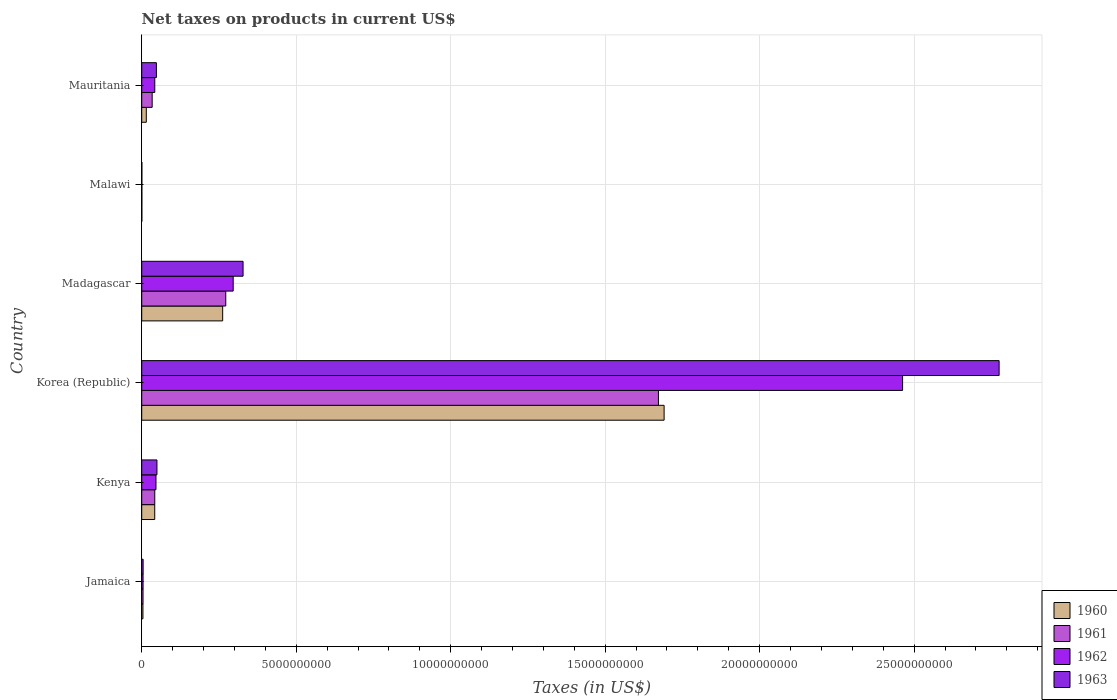How many different coloured bars are there?
Offer a very short reply. 4. How many bars are there on the 6th tick from the bottom?
Make the answer very short. 4. What is the label of the 6th group of bars from the top?
Offer a terse response. Jamaica. In how many cases, is the number of bars for a given country not equal to the number of legend labels?
Provide a short and direct response. 0. What is the net taxes on products in 1963 in Kenya?
Your response must be concise. 4.93e+08. Across all countries, what is the maximum net taxes on products in 1961?
Give a very brief answer. 1.67e+1. Across all countries, what is the minimum net taxes on products in 1960?
Offer a terse response. 3.90e+06. In which country was the net taxes on products in 1962 maximum?
Make the answer very short. Korea (Republic). In which country was the net taxes on products in 1960 minimum?
Your answer should be compact. Malawi. What is the total net taxes on products in 1963 in the graph?
Offer a very short reply. 3.20e+1. What is the difference between the net taxes on products in 1961 in Jamaica and that in Madagascar?
Ensure brevity in your answer.  -2.68e+09. What is the difference between the net taxes on products in 1961 in Mauritania and the net taxes on products in 1960 in Madagascar?
Provide a short and direct response. -2.28e+09. What is the average net taxes on products in 1963 per country?
Keep it short and to the point. 5.34e+09. What is the difference between the net taxes on products in 1960 and net taxes on products in 1963 in Malawi?
Offer a terse response. -7.00e+05. What is the ratio of the net taxes on products in 1960 in Jamaica to that in Malawi?
Provide a succinct answer. 10.08. Is the net taxes on products in 1961 in Kenya less than that in Madagascar?
Keep it short and to the point. Yes. What is the difference between the highest and the second highest net taxes on products in 1962?
Ensure brevity in your answer.  2.17e+1. What is the difference between the highest and the lowest net taxes on products in 1962?
Offer a very short reply. 2.46e+1. Is it the case that in every country, the sum of the net taxes on products in 1962 and net taxes on products in 1963 is greater than the sum of net taxes on products in 1961 and net taxes on products in 1960?
Provide a succinct answer. No. What does the 2nd bar from the top in Madagascar represents?
Make the answer very short. 1962. What does the 4th bar from the bottom in Kenya represents?
Offer a terse response. 1963. How many bars are there?
Keep it short and to the point. 24. What is the difference between two consecutive major ticks on the X-axis?
Make the answer very short. 5.00e+09. Are the values on the major ticks of X-axis written in scientific E-notation?
Ensure brevity in your answer.  No. Where does the legend appear in the graph?
Ensure brevity in your answer.  Bottom right. How many legend labels are there?
Ensure brevity in your answer.  4. What is the title of the graph?
Your answer should be very brief. Net taxes on products in current US$. Does "1963" appear as one of the legend labels in the graph?
Provide a short and direct response. Yes. What is the label or title of the X-axis?
Your answer should be very brief. Taxes (in US$). What is the Taxes (in US$) in 1960 in Jamaica?
Your answer should be compact. 3.93e+07. What is the Taxes (in US$) in 1961 in Jamaica?
Give a very brief answer. 4.26e+07. What is the Taxes (in US$) of 1962 in Jamaica?
Your response must be concise. 4.35e+07. What is the Taxes (in US$) of 1963 in Jamaica?
Provide a short and direct response. 4.54e+07. What is the Taxes (in US$) of 1960 in Kenya?
Provide a short and direct response. 4.21e+08. What is the Taxes (in US$) in 1961 in Kenya?
Your answer should be compact. 4.22e+08. What is the Taxes (in US$) of 1962 in Kenya?
Your answer should be compact. 4.62e+08. What is the Taxes (in US$) of 1963 in Kenya?
Provide a succinct answer. 4.93e+08. What is the Taxes (in US$) in 1960 in Korea (Republic)?
Offer a very short reply. 1.69e+1. What is the Taxes (in US$) in 1961 in Korea (Republic)?
Offer a very short reply. 1.67e+1. What is the Taxes (in US$) in 1962 in Korea (Republic)?
Give a very brief answer. 2.46e+1. What is the Taxes (in US$) in 1963 in Korea (Republic)?
Ensure brevity in your answer.  2.77e+1. What is the Taxes (in US$) in 1960 in Madagascar?
Give a very brief answer. 2.62e+09. What is the Taxes (in US$) of 1961 in Madagascar?
Offer a very short reply. 2.72e+09. What is the Taxes (in US$) in 1962 in Madagascar?
Your answer should be compact. 2.96e+09. What is the Taxes (in US$) in 1963 in Madagascar?
Give a very brief answer. 3.28e+09. What is the Taxes (in US$) of 1960 in Malawi?
Keep it short and to the point. 3.90e+06. What is the Taxes (in US$) of 1961 in Malawi?
Offer a very short reply. 4.20e+06. What is the Taxes (in US$) of 1962 in Malawi?
Keep it short and to the point. 4.40e+06. What is the Taxes (in US$) of 1963 in Malawi?
Offer a very short reply. 4.60e+06. What is the Taxes (in US$) in 1960 in Mauritania?
Your answer should be compact. 1.48e+08. What is the Taxes (in US$) in 1961 in Mauritania?
Your answer should be very brief. 3.38e+08. What is the Taxes (in US$) in 1962 in Mauritania?
Keep it short and to the point. 4.23e+08. What is the Taxes (in US$) of 1963 in Mauritania?
Your answer should be very brief. 4.75e+08. Across all countries, what is the maximum Taxes (in US$) of 1960?
Offer a very short reply. 1.69e+1. Across all countries, what is the maximum Taxes (in US$) in 1961?
Make the answer very short. 1.67e+1. Across all countries, what is the maximum Taxes (in US$) of 1962?
Your answer should be compact. 2.46e+1. Across all countries, what is the maximum Taxes (in US$) of 1963?
Provide a short and direct response. 2.77e+1. Across all countries, what is the minimum Taxes (in US$) in 1960?
Offer a very short reply. 3.90e+06. Across all countries, what is the minimum Taxes (in US$) of 1961?
Offer a terse response. 4.20e+06. Across all countries, what is the minimum Taxes (in US$) in 1962?
Give a very brief answer. 4.40e+06. Across all countries, what is the minimum Taxes (in US$) of 1963?
Make the answer very short. 4.60e+06. What is the total Taxes (in US$) in 1960 in the graph?
Make the answer very short. 2.01e+1. What is the total Taxes (in US$) in 1961 in the graph?
Your answer should be very brief. 2.03e+1. What is the total Taxes (in US$) in 1962 in the graph?
Ensure brevity in your answer.  2.85e+1. What is the total Taxes (in US$) in 1963 in the graph?
Offer a terse response. 3.20e+1. What is the difference between the Taxes (in US$) of 1960 in Jamaica and that in Kenya?
Your answer should be compact. -3.82e+08. What is the difference between the Taxes (in US$) in 1961 in Jamaica and that in Kenya?
Provide a short and direct response. -3.79e+08. What is the difference between the Taxes (in US$) in 1962 in Jamaica and that in Kenya?
Provide a succinct answer. -4.18e+08. What is the difference between the Taxes (in US$) in 1963 in Jamaica and that in Kenya?
Your answer should be compact. -4.48e+08. What is the difference between the Taxes (in US$) of 1960 in Jamaica and that in Korea (Republic)?
Your response must be concise. -1.69e+1. What is the difference between the Taxes (in US$) of 1961 in Jamaica and that in Korea (Republic)?
Offer a terse response. -1.67e+1. What is the difference between the Taxes (in US$) in 1962 in Jamaica and that in Korea (Republic)?
Make the answer very short. -2.46e+1. What is the difference between the Taxes (in US$) of 1963 in Jamaica and that in Korea (Republic)?
Your answer should be compact. -2.77e+1. What is the difference between the Taxes (in US$) in 1960 in Jamaica and that in Madagascar?
Your answer should be compact. -2.58e+09. What is the difference between the Taxes (in US$) of 1961 in Jamaica and that in Madagascar?
Ensure brevity in your answer.  -2.68e+09. What is the difference between the Taxes (in US$) in 1962 in Jamaica and that in Madagascar?
Offer a terse response. -2.92e+09. What is the difference between the Taxes (in US$) of 1963 in Jamaica and that in Madagascar?
Keep it short and to the point. -3.23e+09. What is the difference between the Taxes (in US$) of 1960 in Jamaica and that in Malawi?
Your answer should be very brief. 3.54e+07. What is the difference between the Taxes (in US$) in 1961 in Jamaica and that in Malawi?
Provide a short and direct response. 3.84e+07. What is the difference between the Taxes (in US$) in 1962 in Jamaica and that in Malawi?
Your answer should be very brief. 3.91e+07. What is the difference between the Taxes (in US$) in 1963 in Jamaica and that in Malawi?
Make the answer very short. 4.08e+07. What is the difference between the Taxes (in US$) of 1960 in Jamaica and that in Mauritania?
Give a very brief answer. -1.09e+08. What is the difference between the Taxes (in US$) of 1961 in Jamaica and that in Mauritania?
Give a very brief answer. -2.95e+08. What is the difference between the Taxes (in US$) of 1962 in Jamaica and that in Mauritania?
Provide a succinct answer. -3.79e+08. What is the difference between the Taxes (in US$) in 1963 in Jamaica and that in Mauritania?
Provide a succinct answer. -4.30e+08. What is the difference between the Taxes (in US$) in 1960 in Kenya and that in Korea (Republic)?
Provide a succinct answer. -1.65e+1. What is the difference between the Taxes (in US$) in 1961 in Kenya and that in Korea (Republic)?
Ensure brevity in your answer.  -1.63e+1. What is the difference between the Taxes (in US$) of 1962 in Kenya and that in Korea (Republic)?
Ensure brevity in your answer.  -2.42e+1. What is the difference between the Taxes (in US$) in 1963 in Kenya and that in Korea (Republic)?
Offer a very short reply. -2.73e+1. What is the difference between the Taxes (in US$) in 1960 in Kenya and that in Madagascar?
Provide a short and direct response. -2.20e+09. What is the difference between the Taxes (in US$) in 1961 in Kenya and that in Madagascar?
Your answer should be very brief. -2.30e+09. What is the difference between the Taxes (in US$) in 1962 in Kenya and that in Madagascar?
Offer a terse response. -2.50e+09. What is the difference between the Taxes (in US$) in 1963 in Kenya and that in Madagascar?
Make the answer very short. -2.79e+09. What is the difference between the Taxes (in US$) in 1960 in Kenya and that in Malawi?
Give a very brief answer. 4.17e+08. What is the difference between the Taxes (in US$) of 1961 in Kenya and that in Malawi?
Give a very brief answer. 4.18e+08. What is the difference between the Taxes (in US$) in 1962 in Kenya and that in Malawi?
Keep it short and to the point. 4.57e+08. What is the difference between the Taxes (in US$) in 1963 in Kenya and that in Malawi?
Offer a terse response. 4.88e+08. What is the difference between the Taxes (in US$) in 1960 in Kenya and that in Mauritania?
Give a very brief answer. 2.73e+08. What is the difference between the Taxes (in US$) in 1961 in Kenya and that in Mauritania?
Keep it short and to the point. 8.39e+07. What is the difference between the Taxes (in US$) of 1962 in Kenya and that in Mauritania?
Keep it short and to the point. 3.92e+07. What is the difference between the Taxes (in US$) in 1963 in Kenya and that in Mauritania?
Your answer should be very brief. 1.76e+07. What is the difference between the Taxes (in US$) in 1960 in Korea (Republic) and that in Madagascar?
Your answer should be very brief. 1.43e+1. What is the difference between the Taxes (in US$) of 1961 in Korea (Republic) and that in Madagascar?
Make the answer very short. 1.40e+1. What is the difference between the Taxes (in US$) of 1962 in Korea (Republic) and that in Madagascar?
Your answer should be very brief. 2.17e+1. What is the difference between the Taxes (in US$) of 1963 in Korea (Republic) and that in Madagascar?
Offer a terse response. 2.45e+1. What is the difference between the Taxes (in US$) of 1960 in Korea (Republic) and that in Malawi?
Ensure brevity in your answer.  1.69e+1. What is the difference between the Taxes (in US$) in 1961 in Korea (Republic) and that in Malawi?
Make the answer very short. 1.67e+1. What is the difference between the Taxes (in US$) in 1962 in Korea (Republic) and that in Malawi?
Provide a succinct answer. 2.46e+1. What is the difference between the Taxes (in US$) in 1963 in Korea (Republic) and that in Malawi?
Provide a succinct answer. 2.77e+1. What is the difference between the Taxes (in US$) in 1960 in Korea (Republic) and that in Mauritania?
Give a very brief answer. 1.68e+1. What is the difference between the Taxes (in US$) of 1961 in Korea (Republic) and that in Mauritania?
Ensure brevity in your answer.  1.64e+1. What is the difference between the Taxes (in US$) in 1962 in Korea (Republic) and that in Mauritania?
Make the answer very short. 2.42e+1. What is the difference between the Taxes (in US$) in 1963 in Korea (Republic) and that in Mauritania?
Your answer should be very brief. 2.73e+1. What is the difference between the Taxes (in US$) of 1960 in Madagascar and that in Malawi?
Ensure brevity in your answer.  2.62e+09. What is the difference between the Taxes (in US$) in 1961 in Madagascar and that in Malawi?
Give a very brief answer. 2.72e+09. What is the difference between the Taxes (in US$) in 1962 in Madagascar and that in Malawi?
Ensure brevity in your answer.  2.96e+09. What is the difference between the Taxes (in US$) in 1963 in Madagascar and that in Malawi?
Keep it short and to the point. 3.28e+09. What is the difference between the Taxes (in US$) in 1960 in Madagascar and that in Mauritania?
Give a very brief answer. 2.47e+09. What is the difference between the Taxes (in US$) in 1961 in Madagascar and that in Mauritania?
Provide a short and direct response. 2.38e+09. What is the difference between the Taxes (in US$) in 1962 in Madagascar and that in Mauritania?
Your answer should be very brief. 2.54e+09. What is the difference between the Taxes (in US$) in 1963 in Madagascar and that in Mauritania?
Provide a succinct answer. 2.80e+09. What is the difference between the Taxes (in US$) of 1960 in Malawi and that in Mauritania?
Ensure brevity in your answer.  -1.44e+08. What is the difference between the Taxes (in US$) of 1961 in Malawi and that in Mauritania?
Give a very brief answer. -3.34e+08. What is the difference between the Taxes (in US$) of 1962 in Malawi and that in Mauritania?
Provide a short and direct response. -4.18e+08. What is the difference between the Taxes (in US$) of 1963 in Malawi and that in Mauritania?
Your answer should be very brief. -4.71e+08. What is the difference between the Taxes (in US$) of 1960 in Jamaica and the Taxes (in US$) of 1961 in Kenya?
Offer a terse response. -3.83e+08. What is the difference between the Taxes (in US$) in 1960 in Jamaica and the Taxes (in US$) in 1962 in Kenya?
Provide a short and direct response. -4.22e+08. What is the difference between the Taxes (in US$) in 1960 in Jamaica and the Taxes (in US$) in 1963 in Kenya?
Ensure brevity in your answer.  -4.54e+08. What is the difference between the Taxes (in US$) in 1961 in Jamaica and the Taxes (in US$) in 1962 in Kenya?
Offer a terse response. -4.19e+08. What is the difference between the Taxes (in US$) of 1961 in Jamaica and the Taxes (in US$) of 1963 in Kenya?
Your answer should be compact. -4.50e+08. What is the difference between the Taxes (in US$) of 1962 in Jamaica and the Taxes (in US$) of 1963 in Kenya?
Your response must be concise. -4.50e+08. What is the difference between the Taxes (in US$) in 1960 in Jamaica and the Taxes (in US$) in 1961 in Korea (Republic)?
Keep it short and to the point. -1.67e+1. What is the difference between the Taxes (in US$) in 1960 in Jamaica and the Taxes (in US$) in 1962 in Korea (Republic)?
Ensure brevity in your answer.  -2.46e+1. What is the difference between the Taxes (in US$) in 1960 in Jamaica and the Taxes (in US$) in 1963 in Korea (Republic)?
Your response must be concise. -2.77e+1. What is the difference between the Taxes (in US$) in 1961 in Jamaica and the Taxes (in US$) in 1962 in Korea (Republic)?
Offer a very short reply. -2.46e+1. What is the difference between the Taxes (in US$) of 1961 in Jamaica and the Taxes (in US$) of 1963 in Korea (Republic)?
Offer a terse response. -2.77e+1. What is the difference between the Taxes (in US$) in 1962 in Jamaica and the Taxes (in US$) in 1963 in Korea (Republic)?
Your answer should be compact. -2.77e+1. What is the difference between the Taxes (in US$) of 1960 in Jamaica and the Taxes (in US$) of 1961 in Madagascar?
Provide a succinct answer. -2.68e+09. What is the difference between the Taxes (in US$) in 1960 in Jamaica and the Taxes (in US$) in 1962 in Madagascar?
Offer a very short reply. -2.92e+09. What is the difference between the Taxes (in US$) of 1960 in Jamaica and the Taxes (in US$) of 1963 in Madagascar?
Make the answer very short. -3.24e+09. What is the difference between the Taxes (in US$) of 1961 in Jamaica and the Taxes (in US$) of 1962 in Madagascar?
Ensure brevity in your answer.  -2.92e+09. What is the difference between the Taxes (in US$) of 1961 in Jamaica and the Taxes (in US$) of 1963 in Madagascar?
Give a very brief answer. -3.24e+09. What is the difference between the Taxes (in US$) of 1962 in Jamaica and the Taxes (in US$) of 1963 in Madagascar?
Your response must be concise. -3.24e+09. What is the difference between the Taxes (in US$) of 1960 in Jamaica and the Taxes (in US$) of 1961 in Malawi?
Your response must be concise. 3.51e+07. What is the difference between the Taxes (in US$) of 1960 in Jamaica and the Taxes (in US$) of 1962 in Malawi?
Offer a very short reply. 3.49e+07. What is the difference between the Taxes (in US$) of 1960 in Jamaica and the Taxes (in US$) of 1963 in Malawi?
Your answer should be compact. 3.47e+07. What is the difference between the Taxes (in US$) of 1961 in Jamaica and the Taxes (in US$) of 1962 in Malawi?
Offer a very short reply. 3.82e+07. What is the difference between the Taxes (in US$) in 1961 in Jamaica and the Taxes (in US$) in 1963 in Malawi?
Ensure brevity in your answer.  3.80e+07. What is the difference between the Taxes (in US$) of 1962 in Jamaica and the Taxes (in US$) of 1963 in Malawi?
Your answer should be compact. 3.89e+07. What is the difference between the Taxes (in US$) in 1960 in Jamaica and the Taxes (in US$) in 1961 in Mauritania?
Give a very brief answer. -2.99e+08. What is the difference between the Taxes (in US$) of 1960 in Jamaica and the Taxes (in US$) of 1962 in Mauritania?
Make the answer very short. -3.83e+08. What is the difference between the Taxes (in US$) in 1960 in Jamaica and the Taxes (in US$) in 1963 in Mauritania?
Make the answer very short. -4.36e+08. What is the difference between the Taxes (in US$) in 1961 in Jamaica and the Taxes (in US$) in 1962 in Mauritania?
Provide a short and direct response. -3.80e+08. What is the difference between the Taxes (in US$) in 1961 in Jamaica and the Taxes (in US$) in 1963 in Mauritania?
Provide a succinct answer. -4.33e+08. What is the difference between the Taxes (in US$) in 1962 in Jamaica and the Taxes (in US$) in 1963 in Mauritania?
Provide a succinct answer. -4.32e+08. What is the difference between the Taxes (in US$) in 1960 in Kenya and the Taxes (in US$) in 1961 in Korea (Republic)?
Offer a terse response. -1.63e+1. What is the difference between the Taxes (in US$) of 1960 in Kenya and the Taxes (in US$) of 1962 in Korea (Republic)?
Provide a succinct answer. -2.42e+1. What is the difference between the Taxes (in US$) in 1960 in Kenya and the Taxes (in US$) in 1963 in Korea (Republic)?
Offer a very short reply. -2.73e+1. What is the difference between the Taxes (in US$) in 1961 in Kenya and the Taxes (in US$) in 1962 in Korea (Republic)?
Your response must be concise. -2.42e+1. What is the difference between the Taxes (in US$) in 1961 in Kenya and the Taxes (in US$) in 1963 in Korea (Republic)?
Your answer should be compact. -2.73e+1. What is the difference between the Taxes (in US$) of 1962 in Kenya and the Taxes (in US$) of 1963 in Korea (Republic)?
Provide a succinct answer. -2.73e+1. What is the difference between the Taxes (in US$) in 1960 in Kenya and the Taxes (in US$) in 1961 in Madagascar?
Make the answer very short. -2.30e+09. What is the difference between the Taxes (in US$) of 1960 in Kenya and the Taxes (in US$) of 1962 in Madagascar?
Keep it short and to the point. -2.54e+09. What is the difference between the Taxes (in US$) of 1960 in Kenya and the Taxes (in US$) of 1963 in Madagascar?
Provide a succinct answer. -2.86e+09. What is the difference between the Taxes (in US$) of 1961 in Kenya and the Taxes (in US$) of 1962 in Madagascar?
Keep it short and to the point. -2.54e+09. What is the difference between the Taxes (in US$) of 1961 in Kenya and the Taxes (in US$) of 1963 in Madagascar?
Keep it short and to the point. -2.86e+09. What is the difference between the Taxes (in US$) in 1962 in Kenya and the Taxes (in US$) in 1963 in Madagascar?
Offer a terse response. -2.82e+09. What is the difference between the Taxes (in US$) in 1960 in Kenya and the Taxes (in US$) in 1961 in Malawi?
Give a very brief answer. 4.17e+08. What is the difference between the Taxes (in US$) of 1960 in Kenya and the Taxes (in US$) of 1962 in Malawi?
Your answer should be very brief. 4.16e+08. What is the difference between the Taxes (in US$) of 1960 in Kenya and the Taxes (in US$) of 1963 in Malawi?
Give a very brief answer. 4.16e+08. What is the difference between the Taxes (in US$) of 1961 in Kenya and the Taxes (in US$) of 1962 in Malawi?
Provide a short and direct response. 4.18e+08. What is the difference between the Taxes (in US$) of 1961 in Kenya and the Taxes (in US$) of 1963 in Malawi?
Your answer should be compact. 4.17e+08. What is the difference between the Taxes (in US$) of 1962 in Kenya and the Taxes (in US$) of 1963 in Malawi?
Your answer should be very brief. 4.57e+08. What is the difference between the Taxes (in US$) of 1960 in Kenya and the Taxes (in US$) of 1961 in Mauritania?
Make the answer very short. 8.29e+07. What is the difference between the Taxes (in US$) in 1960 in Kenya and the Taxes (in US$) in 1962 in Mauritania?
Your answer should be very brief. -1.66e+06. What is the difference between the Taxes (in US$) in 1960 in Kenya and the Taxes (in US$) in 1963 in Mauritania?
Offer a terse response. -5.45e+07. What is the difference between the Taxes (in US$) of 1961 in Kenya and the Taxes (in US$) of 1962 in Mauritania?
Your response must be concise. -6.60e+05. What is the difference between the Taxes (in US$) of 1961 in Kenya and the Taxes (in US$) of 1963 in Mauritania?
Offer a very short reply. -5.35e+07. What is the difference between the Taxes (in US$) of 1962 in Kenya and the Taxes (in US$) of 1963 in Mauritania?
Your response must be concise. -1.36e+07. What is the difference between the Taxes (in US$) in 1960 in Korea (Republic) and the Taxes (in US$) in 1961 in Madagascar?
Provide a short and direct response. 1.42e+1. What is the difference between the Taxes (in US$) in 1960 in Korea (Republic) and the Taxes (in US$) in 1962 in Madagascar?
Your answer should be very brief. 1.39e+1. What is the difference between the Taxes (in US$) of 1960 in Korea (Republic) and the Taxes (in US$) of 1963 in Madagascar?
Offer a very short reply. 1.36e+1. What is the difference between the Taxes (in US$) in 1961 in Korea (Republic) and the Taxes (in US$) in 1962 in Madagascar?
Offer a very short reply. 1.38e+1. What is the difference between the Taxes (in US$) in 1961 in Korea (Republic) and the Taxes (in US$) in 1963 in Madagascar?
Offer a very short reply. 1.34e+1. What is the difference between the Taxes (in US$) of 1962 in Korea (Republic) and the Taxes (in US$) of 1963 in Madagascar?
Provide a succinct answer. 2.13e+1. What is the difference between the Taxes (in US$) of 1960 in Korea (Republic) and the Taxes (in US$) of 1961 in Malawi?
Offer a terse response. 1.69e+1. What is the difference between the Taxes (in US$) of 1960 in Korea (Republic) and the Taxes (in US$) of 1962 in Malawi?
Provide a short and direct response. 1.69e+1. What is the difference between the Taxes (in US$) of 1960 in Korea (Republic) and the Taxes (in US$) of 1963 in Malawi?
Give a very brief answer. 1.69e+1. What is the difference between the Taxes (in US$) in 1961 in Korea (Republic) and the Taxes (in US$) in 1962 in Malawi?
Provide a short and direct response. 1.67e+1. What is the difference between the Taxes (in US$) in 1961 in Korea (Republic) and the Taxes (in US$) in 1963 in Malawi?
Your answer should be compact. 1.67e+1. What is the difference between the Taxes (in US$) of 1962 in Korea (Republic) and the Taxes (in US$) of 1963 in Malawi?
Give a very brief answer. 2.46e+1. What is the difference between the Taxes (in US$) in 1960 in Korea (Republic) and the Taxes (in US$) in 1961 in Mauritania?
Offer a very short reply. 1.66e+1. What is the difference between the Taxes (in US$) of 1960 in Korea (Republic) and the Taxes (in US$) of 1962 in Mauritania?
Make the answer very short. 1.65e+1. What is the difference between the Taxes (in US$) of 1960 in Korea (Republic) and the Taxes (in US$) of 1963 in Mauritania?
Provide a short and direct response. 1.64e+1. What is the difference between the Taxes (in US$) in 1961 in Korea (Republic) and the Taxes (in US$) in 1962 in Mauritania?
Provide a succinct answer. 1.63e+1. What is the difference between the Taxes (in US$) in 1961 in Korea (Republic) and the Taxes (in US$) in 1963 in Mauritania?
Provide a short and direct response. 1.62e+1. What is the difference between the Taxes (in US$) of 1962 in Korea (Republic) and the Taxes (in US$) of 1963 in Mauritania?
Give a very brief answer. 2.42e+1. What is the difference between the Taxes (in US$) in 1960 in Madagascar and the Taxes (in US$) in 1961 in Malawi?
Offer a terse response. 2.62e+09. What is the difference between the Taxes (in US$) in 1960 in Madagascar and the Taxes (in US$) in 1962 in Malawi?
Your answer should be compact. 2.62e+09. What is the difference between the Taxes (in US$) in 1960 in Madagascar and the Taxes (in US$) in 1963 in Malawi?
Ensure brevity in your answer.  2.62e+09. What is the difference between the Taxes (in US$) in 1961 in Madagascar and the Taxes (in US$) in 1962 in Malawi?
Offer a very short reply. 2.72e+09. What is the difference between the Taxes (in US$) of 1961 in Madagascar and the Taxes (in US$) of 1963 in Malawi?
Give a very brief answer. 2.72e+09. What is the difference between the Taxes (in US$) in 1962 in Madagascar and the Taxes (in US$) in 1963 in Malawi?
Make the answer very short. 2.96e+09. What is the difference between the Taxes (in US$) in 1960 in Madagascar and the Taxes (in US$) in 1961 in Mauritania?
Make the answer very short. 2.28e+09. What is the difference between the Taxes (in US$) of 1960 in Madagascar and the Taxes (in US$) of 1962 in Mauritania?
Your answer should be very brief. 2.20e+09. What is the difference between the Taxes (in US$) of 1960 in Madagascar and the Taxes (in US$) of 1963 in Mauritania?
Ensure brevity in your answer.  2.14e+09. What is the difference between the Taxes (in US$) in 1961 in Madagascar and the Taxes (in US$) in 1962 in Mauritania?
Provide a succinct answer. 2.30e+09. What is the difference between the Taxes (in US$) in 1961 in Madagascar and the Taxes (in US$) in 1963 in Mauritania?
Offer a very short reply. 2.24e+09. What is the difference between the Taxes (in US$) of 1962 in Madagascar and the Taxes (in US$) of 1963 in Mauritania?
Make the answer very short. 2.48e+09. What is the difference between the Taxes (in US$) in 1960 in Malawi and the Taxes (in US$) in 1961 in Mauritania?
Make the answer very short. -3.34e+08. What is the difference between the Taxes (in US$) of 1960 in Malawi and the Taxes (in US$) of 1962 in Mauritania?
Keep it short and to the point. -4.19e+08. What is the difference between the Taxes (in US$) in 1960 in Malawi and the Taxes (in US$) in 1963 in Mauritania?
Your answer should be compact. -4.71e+08. What is the difference between the Taxes (in US$) in 1961 in Malawi and the Taxes (in US$) in 1962 in Mauritania?
Provide a succinct answer. -4.18e+08. What is the difference between the Taxes (in US$) in 1961 in Malawi and the Taxes (in US$) in 1963 in Mauritania?
Give a very brief answer. -4.71e+08. What is the difference between the Taxes (in US$) in 1962 in Malawi and the Taxes (in US$) in 1963 in Mauritania?
Keep it short and to the point. -4.71e+08. What is the average Taxes (in US$) of 1960 per country?
Keep it short and to the point. 3.36e+09. What is the average Taxes (in US$) of 1961 per country?
Ensure brevity in your answer.  3.38e+09. What is the average Taxes (in US$) in 1962 per country?
Make the answer very short. 4.75e+09. What is the average Taxes (in US$) of 1963 per country?
Provide a short and direct response. 5.34e+09. What is the difference between the Taxes (in US$) of 1960 and Taxes (in US$) of 1961 in Jamaica?
Make the answer very short. -3.30e+06. What is the difference between the Taxes (in US$) in 1960 and Taxes (in US$) in 1962 in Jamaica?
Offer a very short reply. -4.20e+06. What is the difference between the Taxes (in US$) of 1960 and Taxes (in US$) of 1963 in Jamaica?
Make the answer very short. -6.10e+06. What is the difference between the Taxes (in US$) of 1961 and Taxes (in US$) of 1962 in Jamaica?
Make the answer very short. -9.00e+05. What is the difference between the Taxes (in US$) in 1961 and Taxes (in US$) in 1963 in Jamaica?
Give a very brief answer. -2.80e+06. What is the difference between the Taxes (in US$) of 1962 and Taxes (in US$) of 1963 in Jamaica?
Provide a succinct answer. -1.90e+06. What is the difference between the Taxes (in US$) of 1960 and Taxes (in US$) of 1961 in Kenya?
Your answer should be compact. -1.00e+06. What is the difference between the Taxes (in US$) in 1960 and Taxes (in US$) in 1962 in Kenya?
Provide a succinct answer. -4.09e+07. What is the difference between the Taxes (in US$) of 1960 and Taxes (in US$) of 1963 in Kenya?
Keep it short and to the point. -7.21e+07. What is the difference between the Taxes (in US$) in 1961 and Taxes (in US$) in 1962 in Kenya?
Give a very brief answer. -3.99e+07. What is the difference between the Taxes (in US$) of 1961 and Taxes (in US$) of 1963 in Kenya?
Offer a very short reply. -7.11e+07. What is the difference between the Taxes (in US$) in 1962 and Taxes (in US$) in 1963 in Kenya?
Provide a succinct answer. -3.12e+07. What is the difference between the Taxes (in US$) in 1960 and Taxes (in US$) in 1961 in Korea (Republic)?
Give a very brief answer. 1.84e+08. What is the difference between the Taxes (in US$) in 1960 and Taxes (in US$) in 1962 in Korea (Republic)?
Your response must be concise. -7.72e+09. What is the difference between the Taxes (in US$) of 1960 and Taxes (in US$) of 1963 in Korea (Republic)?
Your answer should be very brief. -1.08e+1. What is the difference between the Taxes (in US$) in 1961 and Taxes (in US$) in 1962 in Korea (Republic)?
Your answer should be very brief. -7.90e+09. What is the difference between the Taxes (in US$) in 1961 and Taxes (in US$) in 1963 in Korea (Republic)?
Offer a terse response. -1.10e+1. What is the difference between the Taxes (in US$) of 1962 and Taxes (in US$) of 1963 in Korea (Republic)?
Your answer should be very brief. -3.12e+09. What is the difference between the Taxes (in US$) of 1960 and Taxes (in US$) of 1961 in Madagascar?
Your response must be concise. -1.00e+08. What is the difference between the Taxes (in US$) in 1960 and Taxes (in US$) in 1962 in Madagascar?
Ensure brevity in your answer.  -3.40e+08. What is the difference between the Taxes (in US$) in 1960 and Taxes (in US$) in 1963 in Madagascar?
Offer a terse response. -6.60e+08. What is the difference between the Taxes (in US$) of 1961 and Taxes (in US$) of 1962 in Madagascar?
Your response must be concise. -2.40e+08. What is the difference between the Taxes (in US$) of 1961 and Taxes (in US$) of 1963 in Madagascar?
Make the answer very short. -5.60e+08. What is the difference between the Taxes (in US$) in 1962 and Taxes (in US$) in 1963 in Madagascar?
Provide a succinct answer. -3.20e+08. What is the difference between the Taxes (in US$) in 1960 and Taxes (in US$) in 1962 in Malawi?
Keep it short and to the point. -5.00e+05. What is the difference between the Taxes (in US$) of 1960 and Taxes (in US$) of 1963 in Malawi?
Your answer should be compact. -7.00e+05. What is the difference between the Taxes (in US$) in 1961 and Taxes (in US$) in 1962 in Malawi?
Your response must be concise. -2.00e+05. What is the difference between the Taxes (in US$) of 1961 and Taxes (in US$) of 1963 in Malawi?
Ensure brevity in your answer.  -4.00e+05. What is the difference between the Taxes (in US$) of 1960 and Taxes (in US$) of 1961 in Mauritania?
Keep it short and to the point. -1.90e+08. What is the difference between the Taxes (in US$) of 1960 and Taxes (in US$) of 1962 in Mauritania?
Offer a very short reply. -2.75e+08. What is the difference between the Taxes (in US$) of 1960 and Taxes (in US$) of 1963 in Mauritania?
Give a very brief answer. -3.27e+08. What is the difference between the Taxes (in US$) in 1961 and Taxes (in US$) in 1962 in Mauritania?
Your answer should be compact. -8.45e+07. What is the difference between the Taxes (in US$) in 1961 and Taxes (in US$) in 1963 in Mauritania?
Provide a short and direct response. -1.37e+08. What is the difference between the Taxes (in US$) of 1962 and Taxes (in US$) of 1963 in Mauritania?
Your answer should be very brief. -5.28e+07. What is the ratio of the Taxes (in US$) in 1960 in Jamaica to that in Kenya?
Keep it short and to the point. 0.09. What is the ratio of the Taxes (in US$) of 1961 in Jamaica to that in Kenya?
Keep it short and to the point. 0.1. What is the ratio of the Taxes (in US$) of 1962 in Jamaica to that in Kenya?
Offer a very short reply. 0.09. What is the ratio of the Taxes (in US$) of 1963 in Jamaica to that in Kenya?
Your response must be concise. 0.09. What is the ratio of the Taxes (in US$) in 1960 in Jamaica to that in Korea (Republic)?
Your response must be concise. 0. What is the ratio of the Taxes (in US$) in 1961 in Jamaica to that in Korea (Republic)?
Make the answer very short. 0. What is the ratio of the Taxes (in US$) in 1962 in Jamaica to that in Korea (Republic)?
Provide a short and direct response. 0. What is the ratio of the Taxes (in US$) in 1963 in Jamaica to that in Korea (Republic)?
Make the answer very short. 0. What is the ratio of the Taxes (in US$) of 1960 in Jamaica to that in Madagascar?
Offer a very short reply. 0.01. What is the ratio of the Taxes (in US$) of 1961 in Jamaica to that in Madagascar?
Provide a short and direct response. 0.02. What is the ratio of the Taxes (in US$) in 1962 in Jamaica to that in Madagascar?
Offer a very short reply. 0.01. What is the ratio of the Taxes (in US$) in 1963 in Jamaica to that in Madagascar?
Your response must be concise. 0.01. What is the ratio of the Taxes (in US$) of 1960 in Jamaica to that in Malawi?
Ensure brevity in your answer.  10.08. What is the ratio of the Taxes (in US$) in 1961 in Jamaica to that in Malawi?
Make the answer very short. 10.14. What is the ratio of the Taxes (in US$) of 1962 in Jamaica to that in Malawi?
Make the answer very short. 9.89. What is the ratio of the Taxes (in US$) in 1963 in Jamaica to that in Malawi?
Your answer should be compact. 9.87. What is the ratio of the Taxes (in US$) of 1960 in Jamaica to that in Mauritania?
Your answer should be very brief. 0.27. What is the ratio of the Taxes (in US$) of 1961 in Jamaica to that in Mauritania?
Provide a succinct answer. 0.13. What is the ratio of the Taxes (in US$) in 1962 in Jamaica to that in Mauritania?
Ensure brevity in your answer.  0.1. What is the ratio of the Taxes (in US$) of 1963 in Jamaica to that in Mauritania?
Keep it short and to the point. 0.1. What is the ratio of the Taxes (in US$) in 1960 in Kenya to that in Korea (Republic)?
Offer a very short reply. 0.02. What is the ratio of the Taxes (in US$) of 1961 in Kenya to that in Korea (Republic)?
Offer a very short reply. 0.03. What is the ratio of the Taxes (in US$) in 1962 in Kenya to that in Korea (Republic)?
Provide a succinct answer. 0.02. What is the ratio of the Taxes (in US$) of 1963 in Kenya to that in Korea (Republic)?
Ensure brevity in your answer.  0.02. What is the ratio of the Taxes (in US$) in 1960 in Kenya to that in Madagascar?
Provide a succinct answer. 0.16. What is the ratio of the Taxes (in US$) in 1961 in Kenya to that in Madagascar?
Give a very brief answer. 0.16. What is the ratio of the Taxes (in US$) in 1962 in Kenya to that in Madagascar?
Keep it short and to the point. 0.16. What is the ratio of the Taxes (in US$) of 1963 in Kenya to that in Madagascar?
Make the answer very short. 0.15. What is the ratio of the Taxes (in US$) of 1960 in Kenya to that in Malawi?
Ensure brevity in your answer.  107.92. What is the ratio of the Taxes (in US$) in 1961 in Kenya to that in Malawi?
Your answer should be very brief. 100.45. What is the ratio of the Taxes (in US$) of 1962 in Kenya to that in Malawi?
Offer a terse response. 104.95. What is the ratio of the Taxes (in US$) in 1963 in Kenya to that in Malawi?
Offer a very short reply. 107.17. What is the ratio of the Taxes (in US$) in 1960 in Kenya to that in Mauritania?
Your response must be concise. 2.85. What is the ratio of the Taxes (in US$) in 1961 in Kenya to that in Mauritania?
Offer a terse response. 1.25. What is the ratio of the Taxes (in US$) in 1962 in Kenya to that in Mauritania?
Make the answer very short. 1.09. What is the ratio of the Taxes (in US$) in 1963 in Kenya to that in Mauritania?
Offer a very short reply. 1.04. What is the ratio of the Taxes (in US$) in 1960 in Korea (Republic) to that in Madagascar?
Keep it short and to the point. 6.45. What is the ratio of the Taxes (in US$) of 1961 in Korea (Republic) to that in Madagascar?
Give a very brief answer. 6.15. What is the ratio of the Taxes (in US$) of 1962 in Korea (Republic) to that in Madagascar?
Provide a succinct answer. 8.32. What is the ratio of the Taxes (in US$) of 1963 in Korea (Republic) to that in Madagascar?
Your response must be concise. 8.46. What is the ratio of the Taxes (in US$) of 1960 in Korea (Republic) to that in Malawi?
Your answer should be very brief. 4335.16. What is the ratio of the Taxes (in US$) of 1961 in Korea (Republic) to that in Malawi?
Ensure brevity in your answer.  3981.75. What is the ratio of the Taxes (in US$) in 1962 in Korea (Republic) to that in Malawi?
Ensure brevity in your answer.  5596.72. What is the ratio of the Taxes (in US$) of 1963 in Korea (Republic) to that in Malawi?
Provide a short and direct response. 6032.55. What is the ratio of the Taxes (in US$) in 1960 in Korea (Republic) to that in Mauritania?
Provide a succinct answer. 114.32. What is the ratio of the Taxes (in US$) of 1961 in Korea (Republic) to that in Mauritania?
Offer a terse response. 49.47. What is the ratio of the Taxes (in US$) of 1962 in Korea (Republic) to that in Mauritania?
Your response must be concise. 58.28. What is the ratio of the Taxes (in US$) of 1963 in Korea (Republic) to that in Mauritania?
Give a very brief answer. 58.37. What is the ratio of the Taxes (in US$) in 1960 in Madagascar to that in Malawi?
Offer a terse response. 671.81. What is the ratio of the Taxes (in US$) in 1961 in Madagascar to that in Malawi?
Your response must be concise. 647.63. What is the ratio of the Taxes (in US$) of 1962 in Madagascar to that in Malawi?
Keep it short and to the point. 672.74. What is the ratio of the Taxes (in US$) of 1963 in Madagascar to that in Malawi?
Offer a very short reply. 713.06. What is the ratio of the Taxes (in US$) in 1960 in Madagascar to that in Mauritania?
Your answer should be very brief. 17.72. What is the ratio of the Taxes (in US$) in 1961 in Madagascar to that in Mauritania?
Provide a succinct answer. 8.05. What is the ratio of the Taxes (in US$) in 1962 in Madagascar to that in Mauritania?
Give a very brief answer. 7.01. What is the ratio of the Taxes (in US$) of 1963 in Madagascar to that in Mauritania?
Keep it short and to the point. 6.9. What is the ratio of the Taxes (in US$) in 1960 in Malawi to that in Mauritania?
Your answer should be very brief. 0.03. What is the ratio of the Taxes (in US$) in 1961 in Malawi to that in Mauritania?
Provide a short and direct response. 0.01. What is the ratio of the Taxes (in US$) of 1962 in Malawi to that in Mauritania?
Make the answer very short. 0.01. What is the ratio of the Taxes (in US$) of 1963 in Malawi to that in Mauritania?
Offer a terse response. 0.01. What is the difference between the highest and the second highest Taxes (in US$) in 1960?
Ensure brevity in your answer.  1.43e+1. What is the difference between the highest and the second highest Taxes (in US$) in 1961?
Provide a succinct answer. 1.40e+1. What is the difference between the highest and the second highest Taxes (in US$) in 1962?
Offer a very short reply. 2.17e+1. What is the difference between the highest and the second highest Taxes (in US$) of 1963?
Your answer should be very brief. 2.45e+1. What is the difference between the highest and the lowest Taxes (in US$) in 1960?
Ensure brevity in your answer.  1.69e+1. What is the difference between the highest and the lowest Taxes (in US$) in 1961?
Make the answer very short. 1.67e+1. What is the difference between the highest and the lowest Taxes (in US$) of 1962?
Provide a succinct answer. 2.46e+1. What is the difference between the highest and the lowest Taxes (in US$) of 1963?
Ensure brevity in your answer.  2.77e+1. 